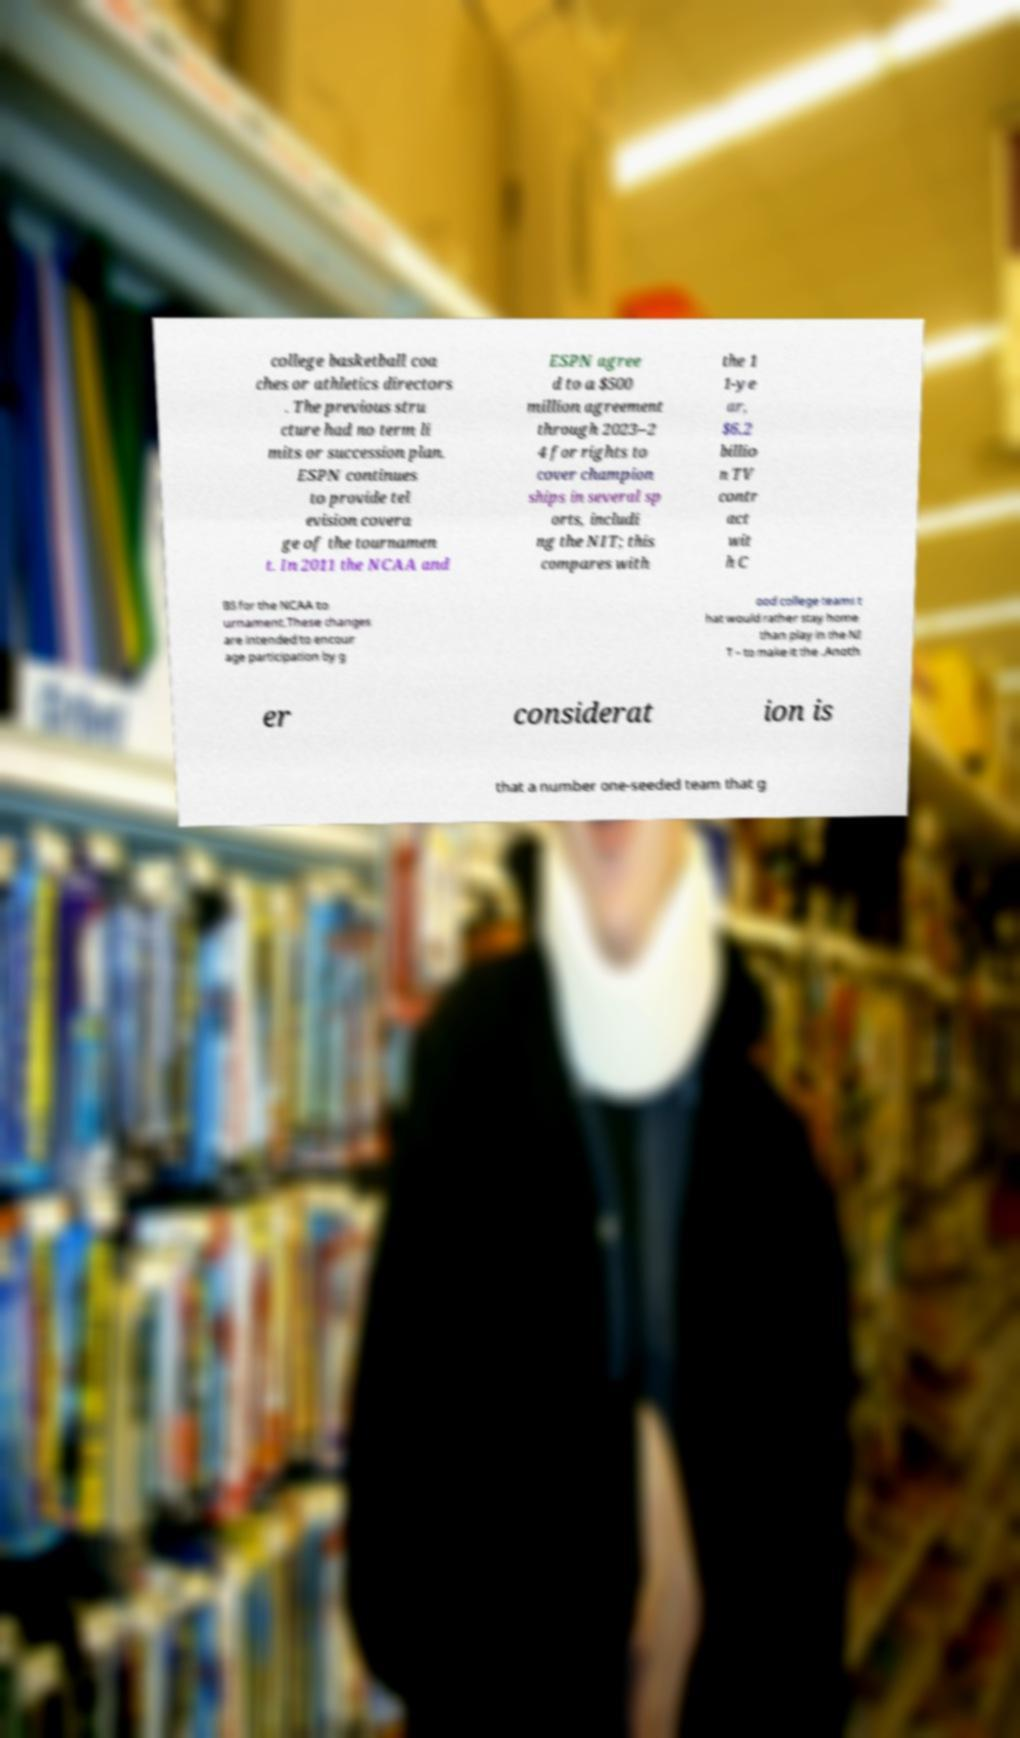I need the written content from this picture converted into text. Can you do that? college basketball coa ches or athletics directors . The previous stru cture had no term li mits or succession plan. ESPN continues to provide tel evision covera ge of the tournamen t. In 2011 the NCAA and ESPN agree d to a $500 million agreement through 2023–2 4 for rights to cover champion ships in several sp orts, includi ng the NIT; this compares with the 1 1-ye ar, $6.2 billio n TV contr act wit h C BS for the NCAA to urnament.These changes are intended to encour age participation by g ood college teams t hat would rather stay home than play in the NI T – to make it the .Anoth er considerat ion is that a number one-seeded team that g 